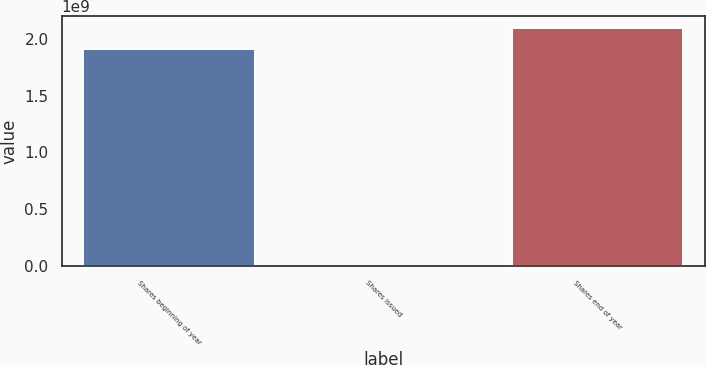Convert chart to OTSL. <chart><loc_0><loc_0><loc_500><loc_500><bar_chart><fcel>Shares beginning of year<fcel>Shares issued<fcel>Shares end of year<nl><fcel>1.90661e+09<fcel>34009<fcel>2.09727e+09<nl></chart> 